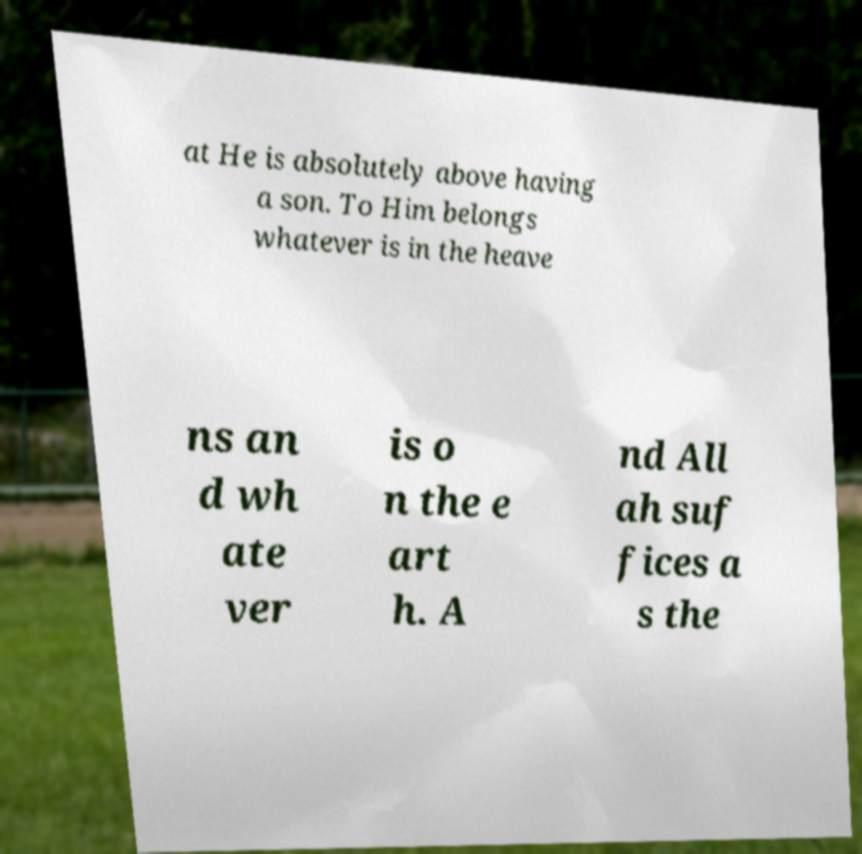Please identify and transcribe the text found in this image. at He is absolutely above having a son. To Him belongs whatever is in the heave ns an d wh ate ver is o n the e art h. A nd All ah suf fices a s the 